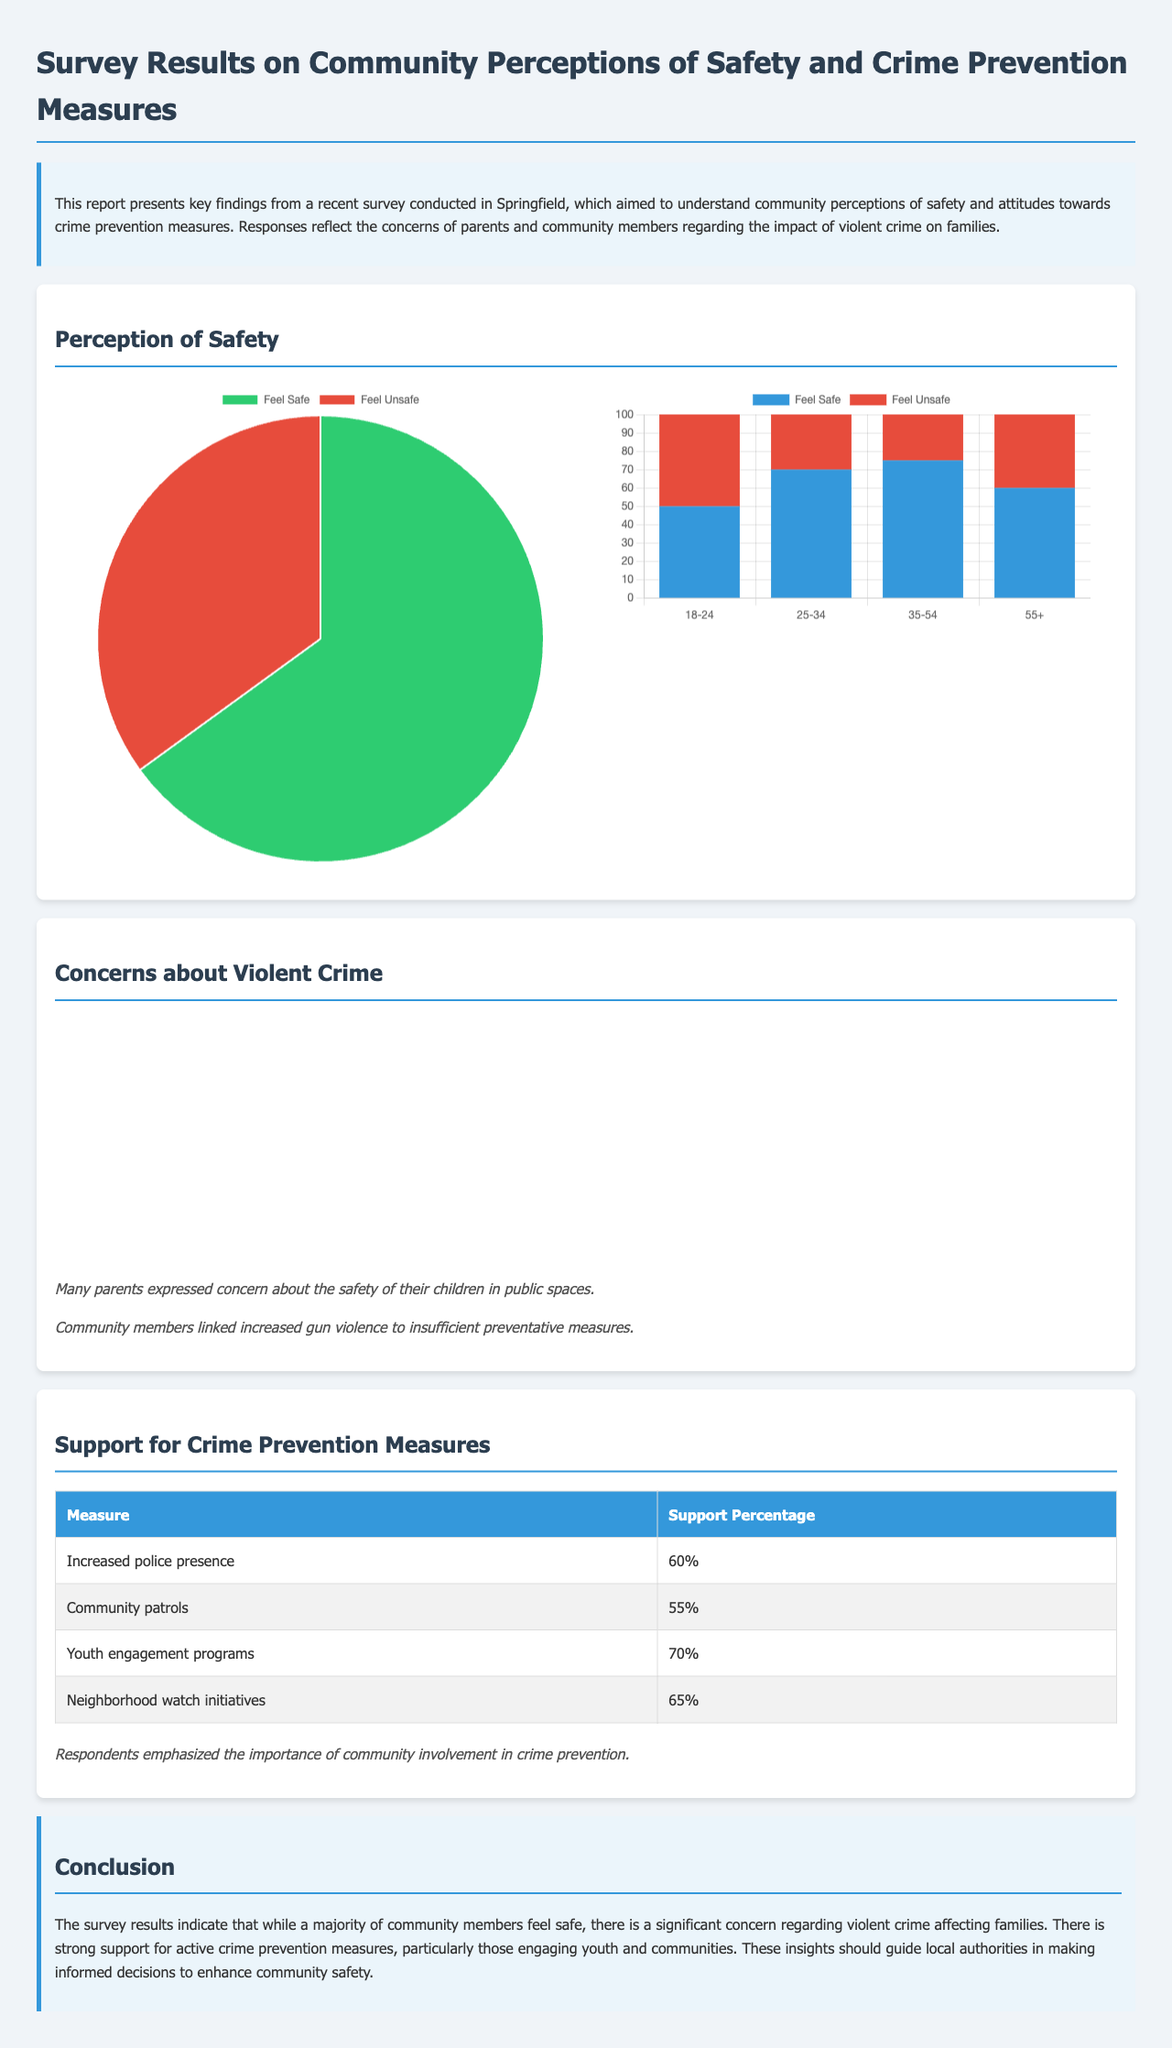What percentage of respondents feel safe? The document states that 65% of respondents feel safe in the survey results.
Answer: 65% What is the primary concern regarding violent crime? The document mentions gun violence as the top concern among respondents.
Answer: Gun violence What crime prevention measure has the highest support? The support percentage table indicates that youth engagement programs received the highest support.
Answer: 70% What percentage of respondents feel unsafe in public spaces? The document specifies that 35% of respondents feel unsafe overall.
Answer: 35% Which age group reported the highest percentage of feeling unsafe? The age safety chart shows that individuals aged 18-24 reported the highest percentage of feeling unsafe.
Answer: 50% What community initiative received a support percentage of 65%? The table in the document lists neighborhood watch initiatives as having 65% support.
Answer: Neighborhood watch initiatives How many concerns about violent crime were identified in the document? The concerns chart highlights four main types of violent crime.
Answer: Four What is the percentage of concern for domestic violence? The document specifies that 30% of respondents expressed concern about domestic violence.
Answer: 30% What is the conclusion drawn from the survey results? The conclusion section summarizes that there is strong support for active crime prevention measures engaging youth and communities.
Answer: Strong support for active crime prevention measures 